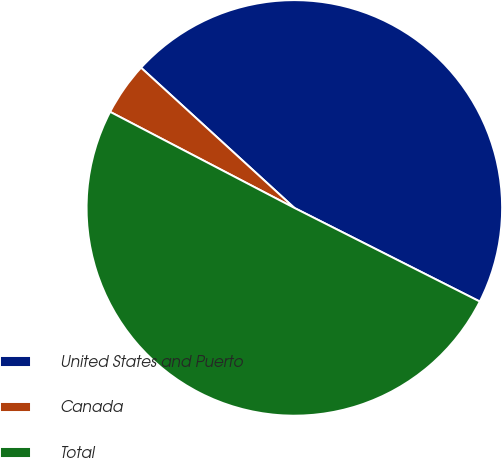<chart> <loc_0><loc_0><loc_500><loc_500><pie_chart><fcel>United States and Puerto<fcel>Canada<fcel>Total<nl><fcel>45.65%<fcel>4.14%<fcel>50.21%<nl></chart> 